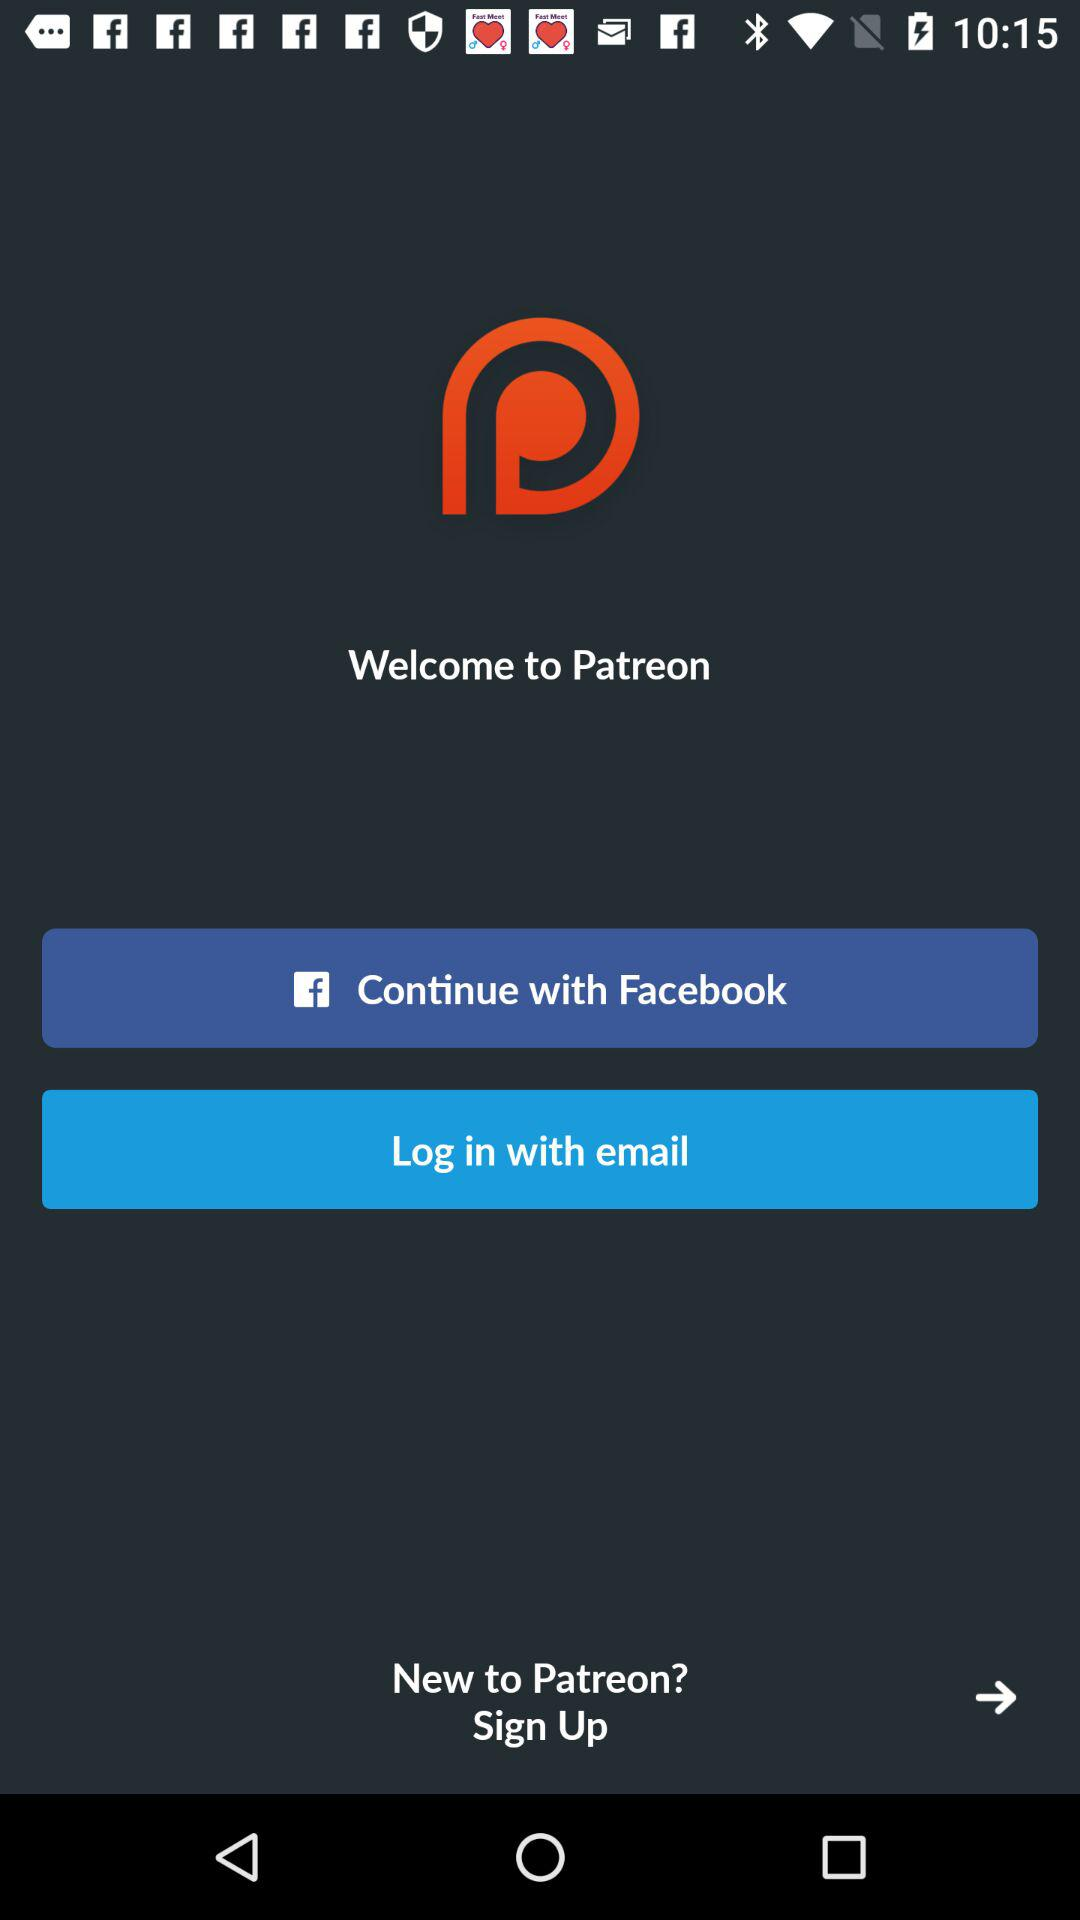What accounts can I use to sign up?
When the provided information is insufficient, respond with <no answer>. <no answer> 